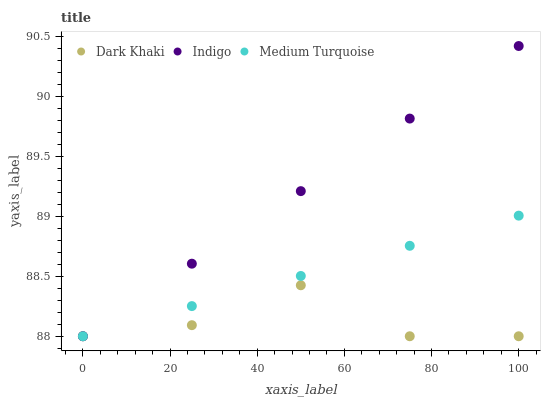Does Dark Khaki have the minimum area under the curve?
Answer yes or no. Yes. Does Indigo have the maximum area under the curve?
Answer yes or no. Yes. Does Medium Turquoise have the minimum area under the curve?
Answer yes or no. No. Does Medium Turquoise have the maximum area under the curve?
Answer yes or no. No. Is Indigo the smoothest?
Answer yes or no. Yes. Is Dark Khaki the roughest?
Answer yes or no. Yes. Is Medium Turquoise the roughest?
Answer yes or no. No. Does Dark Khaki have the lowest value?
Answer yes or no. Yes. Does Indigo have the highest value?
Answer yes or no. Yes. Does Medium Turquoise have the highest value?
Answer yes or no. No. Does Medium Turquoise intersect Dark Khaki?
Answer yes or no. Yes. Is Medium Turquoise less than Dark Khaki?
Answer yes or no. No. Is Medium Turquoise greater than Dark Khaki?
Answer yes or no. No. 